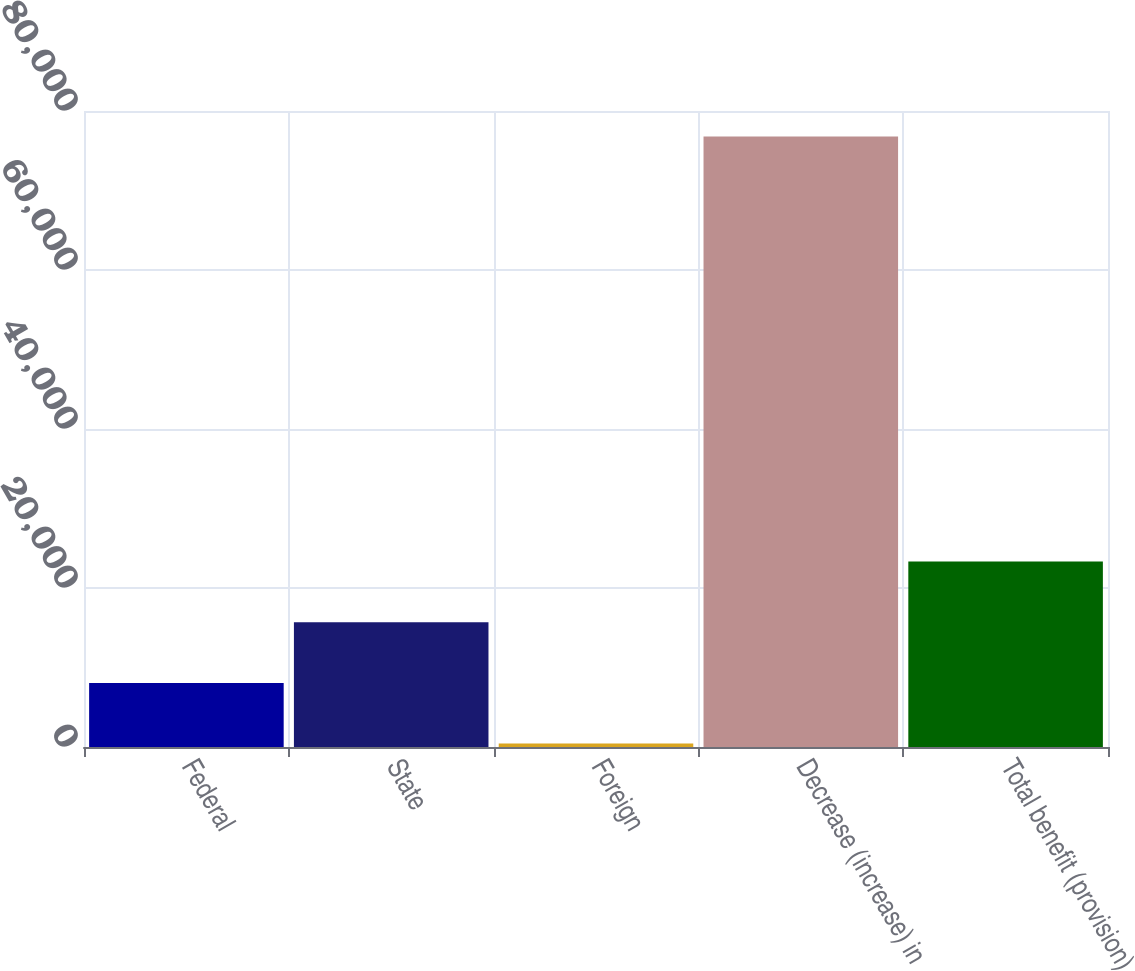Convert chart. <chart><loc_0><loc_0><loc_500><loc_500><bar_chart><fcel>Federal<fcel>State<fcel>Foreign<fcel>Decrease (increase) in<fcel>Total benefit (provision)<nl><fcel>8063.7<fcel>15699.4<fcel>428<fcel>76785<fcel>23335.1<nl></chart> 